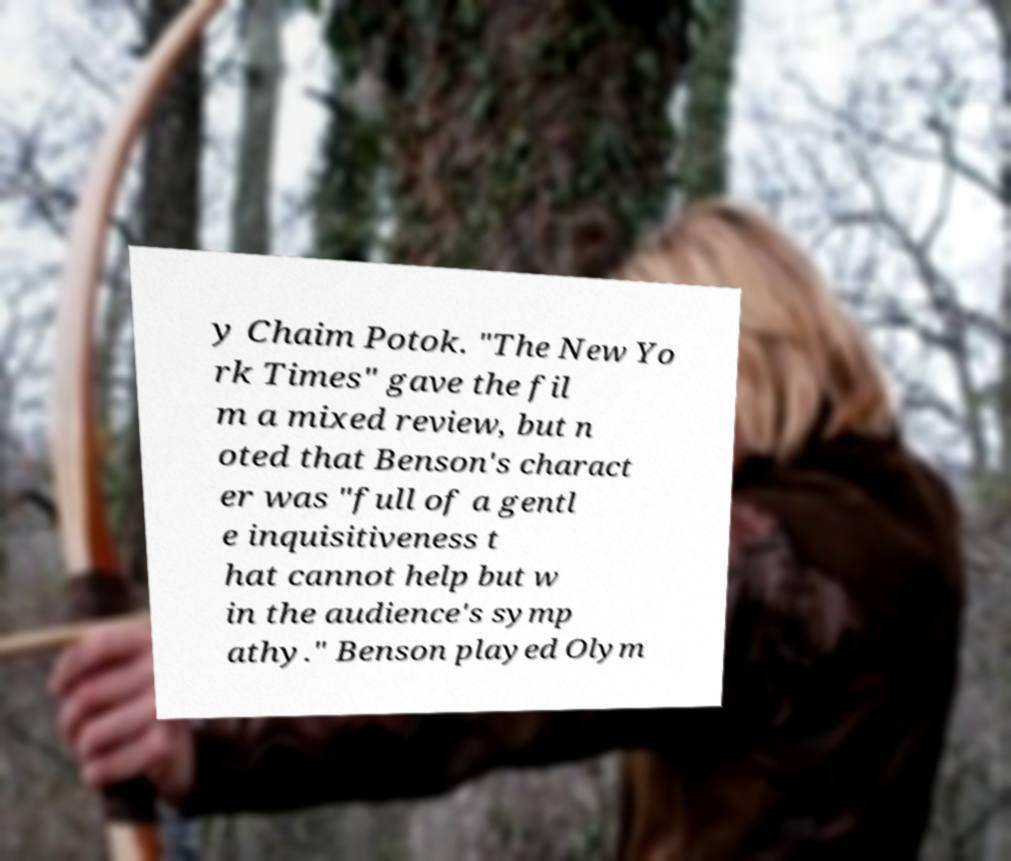Could you extract and type out the text from this image? y Chaim Potok. "The New Yo rk Times" gave the fil m a mixed review, but n oted that Benson's charact er was "full of a gentl e inquisitiveness t hat cannot help but w in the audience's symp athy." Benson played Olym 